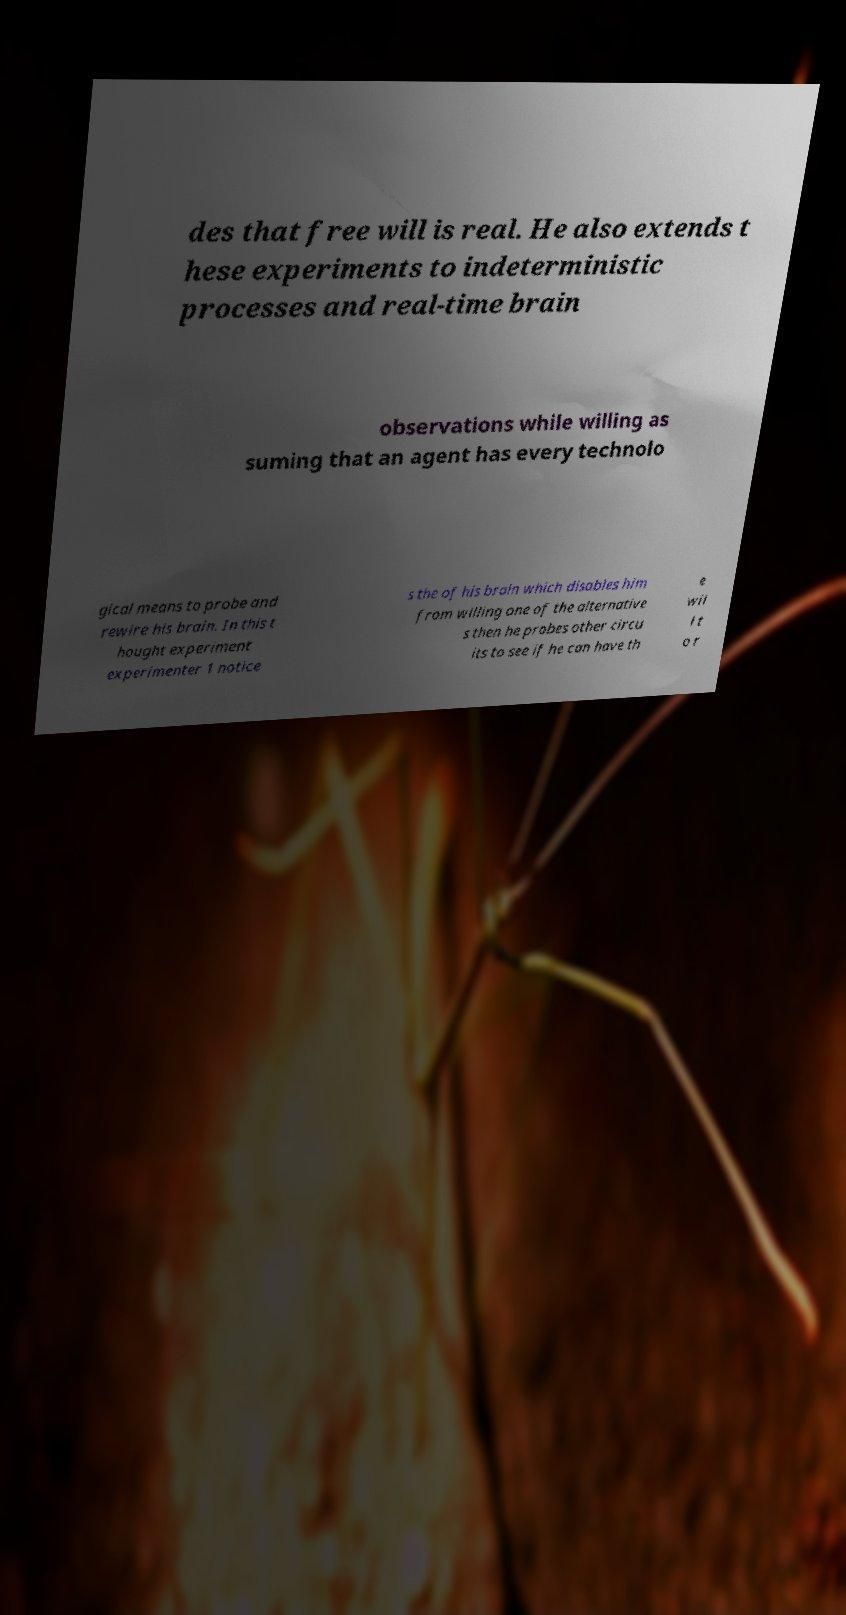I need the written content from this picture converted into text. Can you do that? des that free will is real. He also extends t hese experiments to indeterministic processes and real-time brain observations while willing as suming that an agent has every technolo gical means to probe and rewire his brain. In this t hought experiment experimenter 1 notice s the of his brain which disables him from willing one of the alternative s then he probes other circu its to see if he can have th e wil l t o r 